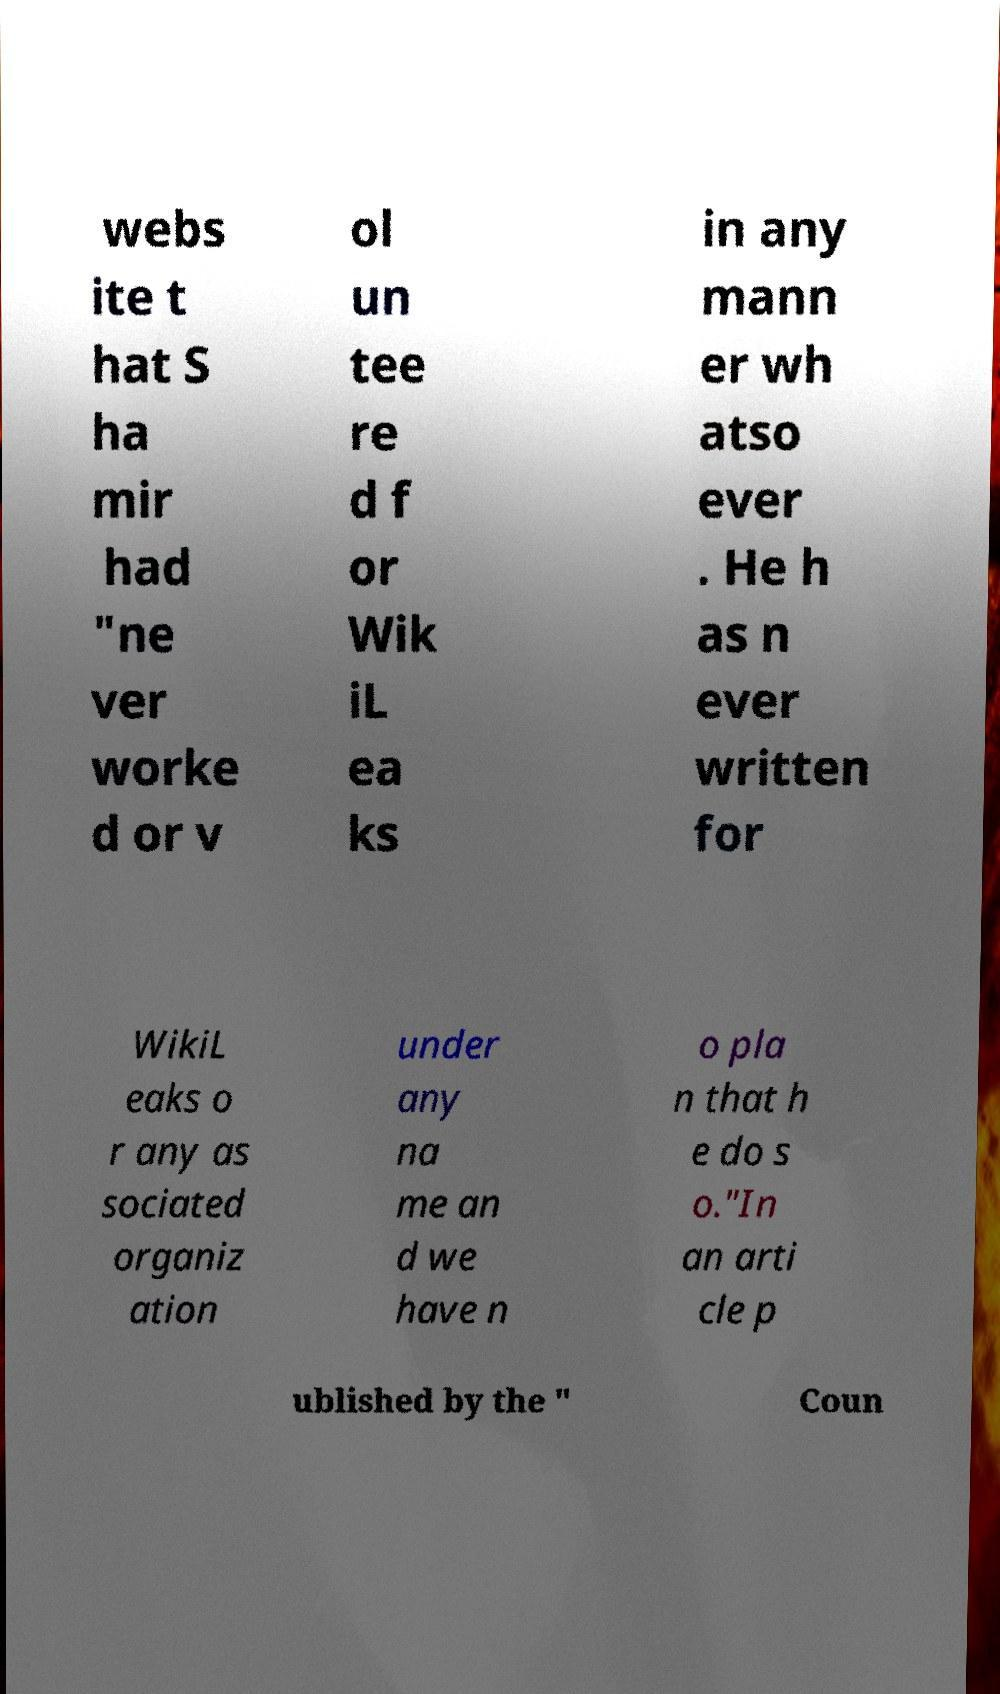Can you accurately transcribe the text from the provided image for me? webs ite t hat S ha mir had "ne ver worke d or v ol un tee re d f or Wik iL ea ks in any mann er wh atso ever . He h as n ever written for WikiL eaks o r any as sociated organiz ation under any na me an d we have n o pla n that h e do s o."In an arti cle p ublished by the " Coun 